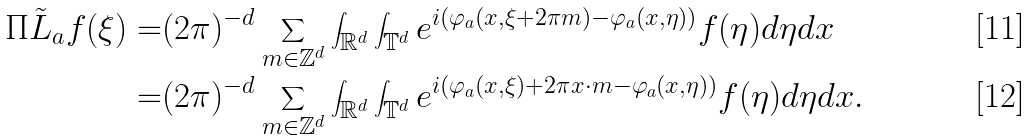Convert formula to latex. <formula><loc_0><loc_0><loc_500><loc_500>\Pi \tilde { L } _ { a } f ( \xi ) = & ( 2 \pi ) ^ { - d } \sum _ { m \in \mathbb { Z } ^ { d } } \int _ { \mathbb { R } ^ { d } } \int _ { \mathbb { T } ^ { d } } e ^ { i ( \varphi _ { a } ( x , \xi + 2 \pi m ) - \varphi _ { a } ( x , \eta ) ) } f ( \eta ) d \eta d x \\ = & ( 2 \pi ) ^ { - d } \sum _ { m \in \mathbb { Z } ^ { d } } \int _ { \mathbb { R } ^ { d } } \int _ { \mathbb { T } ^ { d } } e ^ { i ( \varphi _ { a } ( x , \xi ) + 2 \pi x \cdot m - \varphi _ { a } ( x , \eta ) ) } f ( \eta ) d \eta d x .</formula> 